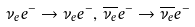<formula> <loc_0><loc_0><loc_500><loc_500>\nu _ { e } e ^ { - } \rightarrow \nu _ { e } e ^ { - } , \, \overline { \nu _ { e } } e ^ { - } \rightarrow \overline { \nu _ { e } } e ^ { - }</formula> 